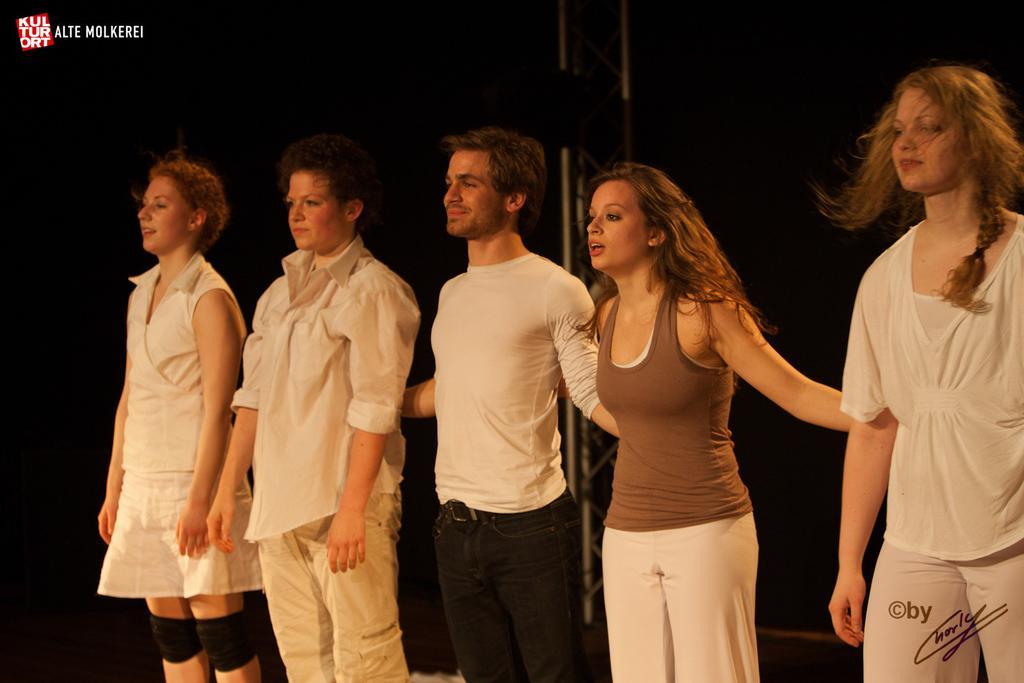Please provide a concise description of this image. In this picture we can see there are five persons standing. Behind the people there is a truss and the dark background. On the image there are watermarks. 